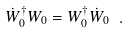<formula> <loc_0><loc_0><loc_500><loc_500>\dot { W } ^ { \dagger } _ { 0 } W _ { 0 } = W ^ { \dagger } _ { 0 } \dot { W } _ { 0 } \ .</formula> 